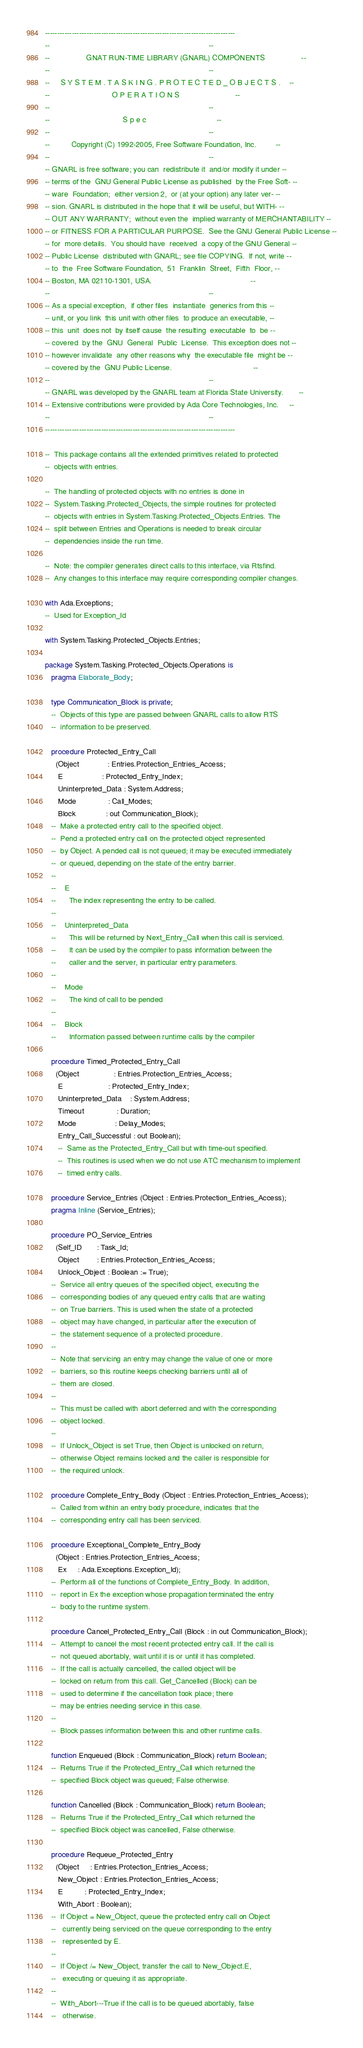Convert code to text. <code><loc_0><loc_0><loc_500><loc_500><_Ada_>------------------------------------------------------------------------------
--                                                                          --
--                 GNAT RUN-TIME LIBRARY (GNARL) COMPONENTS                 --
--                                                                          --
--     S Y S T E M . T A S K I N G . P R O T E C T E D _ O B J E C T S .    --
--                             O P E R A T I O N S                          --
--                                                                          --
--                                  S p e c                                 --
--                                                                          --
--          Copyright (C) 1992-2005, Free Software Foundation, Inc.         --
--                                                                          --
-- GNARL is free software; you can  redistribute it  and/or modify it under --
-- terms of the  GNU General Public License as published  by the Free Soft- --
-- ware  Foundation;  either version 2,  or (at your option) any later ver- --
-- sion. GNARL is distributed in the hope that it will be useful, but WITH- --
-- OUT ANY WARRANTY;  without even the  implied warranty of MERCHANTABILITY --
-- or FITNESS FOR A PARTICULAR PURPOSE.  See the GNU General Public License --
-- for  more details.  You should have  received  a copy of the GNU General --
-- Public License  distributed with GNARL; see file COPYING.  If not, write --
-- to  the  Free Software Foundation,  51  Franklin  Street,  Fifth  Floor, --
-- Boston, MA 02110-1301, USA.                                              --
--                                                                          --
-- As a special exception,  if other files  instantiate  generics from this --
-- unit, or you link  this unit with other files  to produce an executable, --
-- this  unit  does not  by itself cause  the resulting  executable  to  be --
-- covered  by the  GNU  General  Public  License.  This exception does not --
-- however invalidate  any other reasons why  the executable file  might be --
-- covered by the  GNU Public License.                                      --
--                                                                          --
-- GNARL was developed by the GNARL team at Florida State University.       --
-- Extensive contributions were provided by Ada Core Technologies, Inc.     --
--                                                                          --
------------------------------------------------------------------------------

--  This package contains all the extended primitives related to protected
--  objects with entries.

--  The handling of protected objects with no entries is done in
--  System.Tasking.Protected_Objects, the simple routines for protected
--  objects with entries in System.Tasking.Protected_Objects.Entries. The
--  split between Entries and Operations is needed to break circular
--  dependencies inside the run time.

--  Note: the compiler generates direct calls to this interface, via Rtsfind.
--  Any changes to this interface may require corresponding compiler changes.

with Ada.Exceptions;
--  Used for Exception_Id

with System.Tasking.Protected_Objects.Entries;

package System.Tasking.Protected_Objects.Operations is
   pragma Elaborate_Body;

   type Communication_Block is private;
   --  Objects of this type are passed between GNARL calls to allow RTS
   --  information to be preserved.

   procedure Protected_Entry_Call
     (Object             : Entries.Protection_Entries_Access;
      E                  : Protected_Entry_Index;
      Uninterpreted_Data : System.Address;
      Mode               : Call_Modes;
      Block              : out Communication_Block);
   --  Make a protected entry call to the specified object.
   --  Pend a protected entry call on the protected object represented
   --  by Object. A pended call is not queued; it may be executed immediately
   --  or queued, depending on the state of the entry barrier.
   --
   --    E
   --      The index representing the entry to be called.
   --
   --    Uninterpreted_Data
   --      This will be returned by Next_Entry_Call when this call is serviced.
   --      It can be used by the compiler to pass information between the
   --      caller and the server, in particular entry parameters.
   --
   --    Mode
   --      The kind of call to be pended
   --
   --    Block
   --      Information passed between runtime calls by the compiler

   procedure Timed_Protected_Entry_Call
     (Object                : Entries.Protection_Entries_Access;
      E                     : Protected_Entry_Index;
      Uninterpreted_Data    : System.Address;
      Timeout               : Duration;
      Mode                  : Delay_Modes;
      Entry_Call_Successful : out Boolean);
      --  Same as the Protected_Entry_Call but with time-out specified.
      --  This routines is used when we do not use ATC mechanism to implement
      --  timed entry calls.

   procedure Service_Entries (Object : Entries.Protection_Entries_Access);
   pragma Inline (Service_Entries);

   procedure PO_Service_Entries
     (Self_ID       : Task_Id;
      Object        : Entries.Protection_Entries_Access;
      Unlock_Object : Boolean := True);
   --  Service all entry queues of the specified object, executing the
   --  corresponding bodies of any queued entry calls that are waiting
   --  on True barriers. This is used when the state of a protected
   --  object may have changed, in particular after the execution of
   --  the statement sequence of a protected procedure.
   --
   --  Note that servicing an entry may change the value of one or more
   --  barriers, so this routine keeps checking barriers until all of
   --  them are closed.
   --
   --  This must be called with abort deferred and with the corresponding
   --  object locked.
   --
   --  If Unlock_Object is set True, then Object is unlocked on return,
   --  otherwise Object remains locked and the caller is responsible for
   --  the required unlock.

   procedure Complete_Entry_Body (Object : Entries.Protection_Entries_Access);
   --  Called from within an entry body procedure, indicates that the
   --  corresponding entry call has been serviced.

   procedure Exceptional_Complete_Entry_Body
     (Object : Entries.Protection_Entries_Access;
      Ex     : Ada.Exceptions.Exception_Id);
   --  Perform all of the functions of Complete_Entry_Body. In addition,
   --  report in Ex the exception whose propagation terminated the entry
   --  body to the runtime system.

   procedure Cancel_Protected_Entry_Call (Block : in out Communication_Block);
   --  Attempt to cancel the most recent protected entry call. If the call is
   --  not queued abortably, wait until it is or until it has completed.
   --  If the call is actually cancelled, the called object will be
   --  locked on return from this call. Get_Cancelled (Block) can be
   --  used to determine if the cancellation took place; there
   --  may be entries needing service in this case.
   --
   --  Block passes information between this and other runtime calls.

   function Enqueued (Block : Communication_Block) return Boolean;
   --  Returns True if the Protected_Entry_Call which returned the
   --  specified Block object was queued; False otherwise.

   function Cancelled (Block : Communication_Block) return Boolean;
   --  Returns True if the Protected_Entry_Call which returned the
   --  specified Block object was cancelled, False otherwise.

   procedure Requeue_Protected_Entry
     (Object     : Entries.Protection_Entries_Access;
      New_Object : Entries.Protection_Entries_Access;
      E          : Protected_Entry_Index;
      With_Abort : Boolean);
   --  If Object = New_Object, queue the protected entry call on Object
   --   currently being serviced on the queue corresponding to the entry
   --   represented by E.
   --
   --  If Object /= New_Object, transfer the call to New_Object.E,
   --   executing or queuing it as appropriate.
   --
   --  With_Abort---True if the call is to be queued abortably, false
   --   otherwise.
</code> 